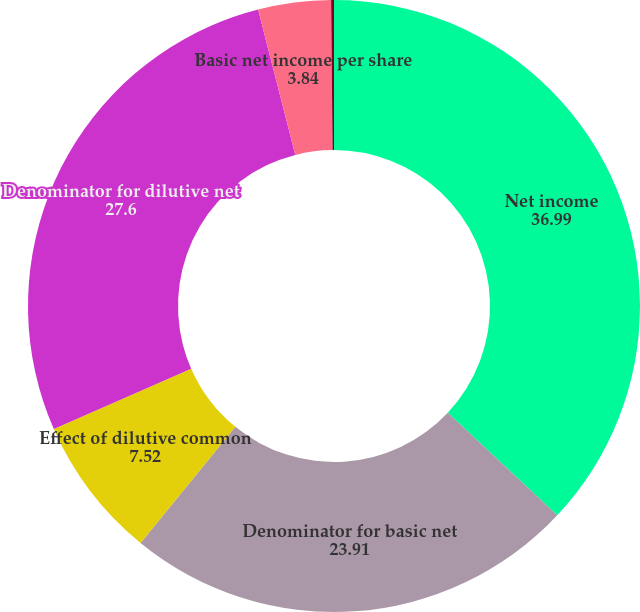Convert chart to OTSL. <chart><loc_0><loc_0><loc_500><loc_500><pie_chart><fcel>Net income<fcel>Denominator for basic net<fcel>Effect of dilutive common<fcel>Denominator for dilutive net<fcel>Basic net income per share<fcel>Diluted net income per share<nl><fcel>36.99%<fcel>23.91%<fcel>7.52%<fcel>27.6%<fcel>3.84%<fcel>0.15%<nl></chart> 